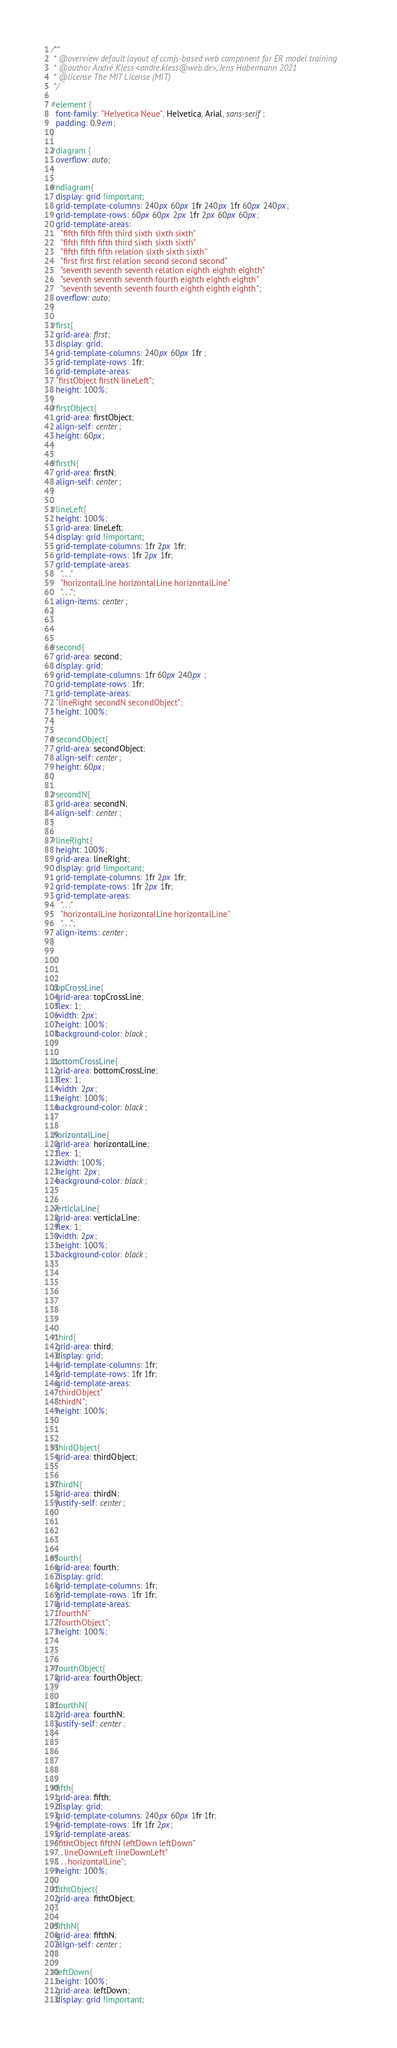Convert code to text. <code><loc_0><loc_0><loc_500><loc_500><_CSS_>/**
 * @overview default layout of ccmjs-based web component for ER model training
 * @author André Kless <andre.kless@web.de>, Jens Habermann 2021
 * @license The MIT License (MIT)
 */

#element {
  font-family: "Helvetica Neue", Helvetica, Arial, sans-serif;
  padding: 0.9em;
}

#diagram {
  overflow: auto; 
}

#ndiagram{
  display: grid !important;
  grid-template-columns: 240px 60px 1fr 240px 1fr 60px 240px;
  grid-template-rows: 60px 60px 2px 1fr 2px 60px 60px;
  grid-template-areas: 
    "fifth fifth fifth third sixth sixth sixth"
    "fifth fifth fifth third sixth sixth sixth"
    "fifth fifth fifth relation sixth sixth sixth"
    "first first first relation second second second"
    "seventh seventh seventh relation eighth eighth eighth"
    "seventh seventh seventh fourth eighth eighth eighth"
    "seventh seventh seventh fourth eighth eighth eighth";
  overflow: auto; 
}

#first{
  grid-area: first;
  display: grid;
  grid-template-columns: 240px 60px 1fr ;
  grid-template-rows: 1fr;
  grid-template-areas: 
  "firstObject firstN lineLeft";
  height: 100%;
}
#firstObject{
  grid-area: firstObject;
  align-self: center;
  height: 60px;
}

#firstN{
  grid-area: firstN;
  align-self: center;
}

#lineLeft{
  height: 100%;
  grid-area: lineLeft;
  display: grid !important;
  grid-template-columns: 1fr 2px 1fr;
  grid-template-rows: 1fr 2px 1fr;
  grid-template-areas: 
    ". . ."
    "horizontalLine horizontalLine horizontalLine"
    ". . .";
  align-items: center;
}



#second{
  grid-area: second;
  display: grid;
  grid-template-columns: 1fr 60px 240px ;
  grid-template-rows: 1fr;
  grid-template-areas: 
  "lineRight secondN secondObject";
  height: 100%;
}

#secondObject{
  grid-area: secondObject;
  align-self: center;
  height: 60px;
}

#secondN{
  grid-area: secondN;
  align-self: center;
}

#lineRight{
  height: 100%;
  grid-area: lineRight;
  display: grid !important;
  grid-template-columns: 1fr 2px 1fr;
  grid-template-rows: 1fr 2px 1fr;
  grid-template-areas: 
    ". . ."
    "horizontalLine horizontalLine horizontalLine"
    ". . .";
  align-items: center;
}




.topCrossLine{
  grid-area: topCrossLine;
  flex: 1;
  width: 2px;
  height: 100%;
  background-color: black;
}

.bottomCrossLine{
  grid-area: bottomCrossLine;
  flex: 1;
  width: 2px;
  height: 100%;
  background-color: black;
}

.horizontalLine{
  grid-area: horizontalLine;
  flex: 1;
  width: 100%;
  height: 2px;
  background-color: black;
}

.verticlaLine{
  grid-area: verticlaLine;
  flex: 1;
  width: 2px;
  height: 100%;
  background-color: black;
}







#third{
  grid-area: third;
  display: grid;
  grid-template-columns: 1fr;
  grid-template-rows: 1fr 1fr;
  grid-template-areas: 
  "thirdObject"
  "thirdN";
  height: 100%;
}


#thirdObject{
  grid-area: thirdObject;
}

#thirdN{
  grid-area: thirdN;
  justify-self: center;
}




#fourth{
  grid-area: fourth;
  display: grid;
  grid-template-columns: 1fr;
  grid-template-rows: 1fr 1fr;
  grid-template-areas: 
  "fourthN"
  "fourthObject";
  height: 100%;
  
}

#fourthObject{
  grid-area: fourthObject;
}

#fourthN{
  grid-area: fourthN;
  justify-self: center;
}





#fifth{
  grid-area: fifth;
  display: grid;
  grid-template-columns: 240px 60px 1fr 1fr;
  grid-template-rows: 1fr 1fr 2px;
  grid-template-areas: 
  "fithtObject fifthN leftDown leftDown"
  ". . lineDownLeft lineDownLeft"
  ". . . horizontalLine";
  height: 100%;
}
#fithtObject{
  grid-area: fithtObject;
}

#fifthN{
  grid-area: fifthN;
  align-self: center;
}

#leftDown{
  height: 100%;
  grid-area: leftDown;
  display: grid !important;</code> 